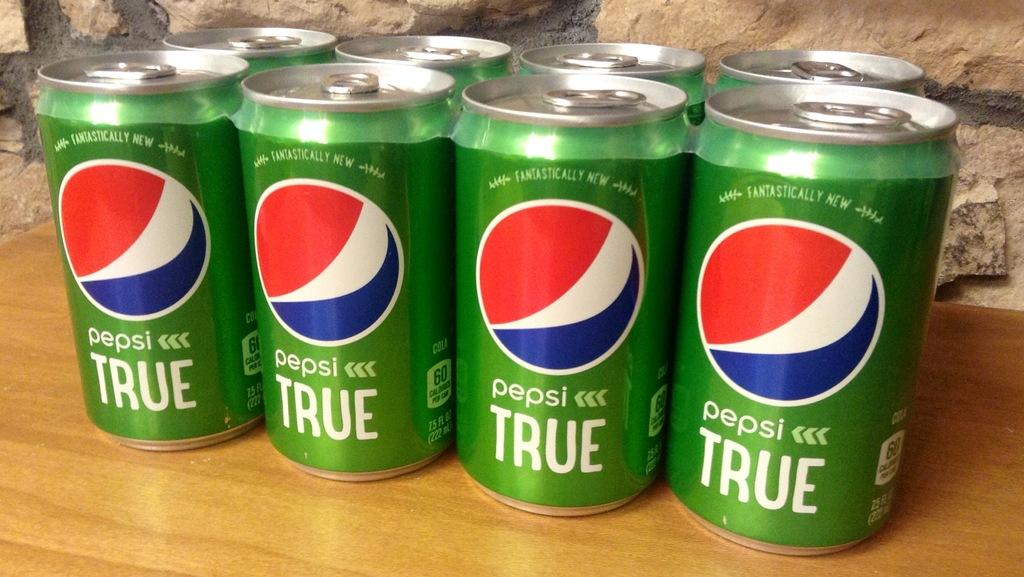<image>
Present a compact description of the photo's key features. An eight-pack of green cans with pepsi TRUE labels. 